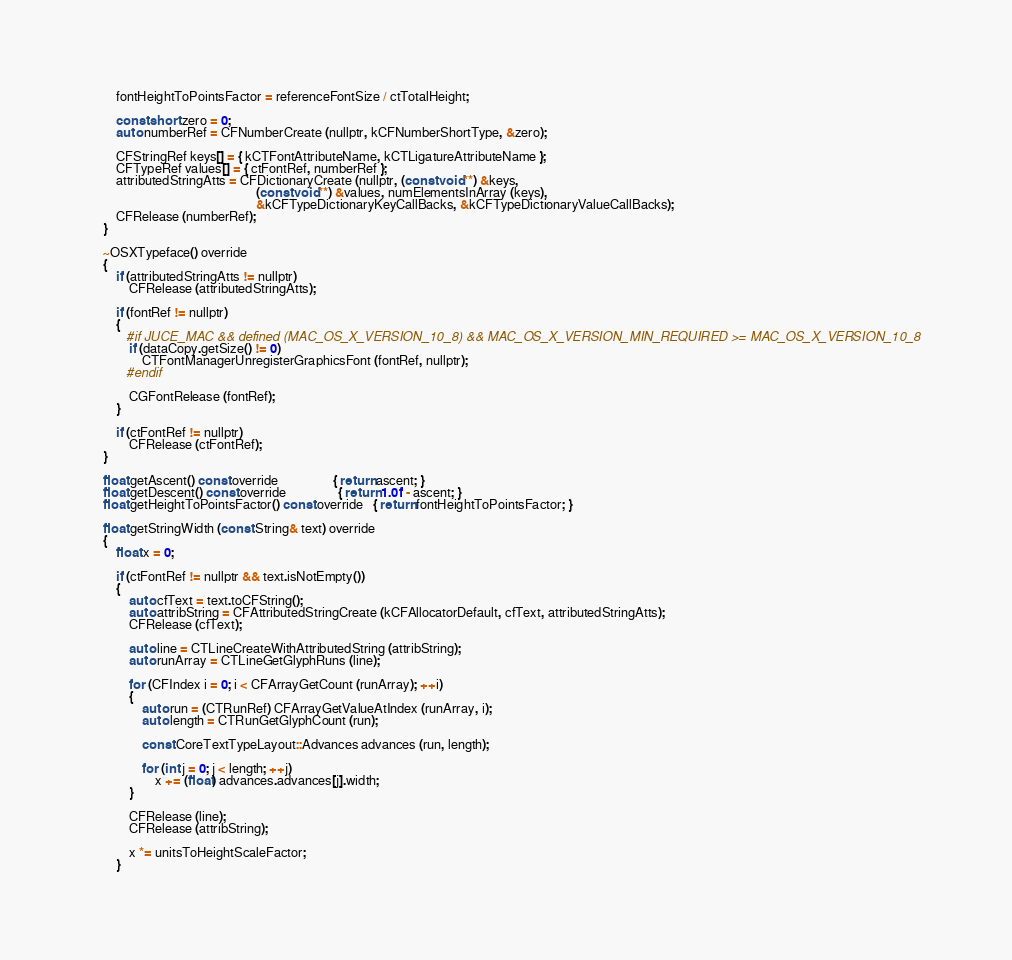Convert code to text. <code><loc_0><loc_0><loc_500><loc_500><_ObjectiveC_>
        fontHeightToPointsFactor = referenceFontSize / ctTotalHeight;

        const short zero = 0;
        auto numberRef = CFNumberCreate (nullptr, kCFNumberShortType, &zero);

        CFStringRef keys[] = { kCTFontAttributeName, kCTLigatureAttributeName };
        CFTypeRef values[] = { ctFontRef, numberRef };
        attributedStringAtts = CFDictionaryCreate (nullptr, (const void**) &keys,
                                                   (const void**) &values, numElementsInArray (keys),
                                                   &kCFTypeDictionaryKeyCallBacks, &kCFTypeDictionaryValueCallBacks);
        CFRelease (numberRef);
    }

    ~OSXTypeface() override
    {
        if (attributedStringAtts != nullptr)
            CFRelease (attributedStringAtts);

        if (fontRef != nullptr)
        {
           #if JUCE_MAC && defined (MAC_OS_X_VERSION_10_8) && MAC_OS_X_VERSION_MIN_REQUIRED >= MAC_OS_X_VERSION_10_8
            if (dataCopy.getSize() != 0)
                CTFontManagerUnregisterGraphicsFont (fontRef, nullptr);
           #endif

            CGFontRelease (fontRef);
        }

        if (ctFontRef != nullptr)
            CFRelease (ctFontRef);
    }

    float getAscent() const override                 { return ascent; }
    float getDescent() const override                { return 1.0f - ascent; }
    float getHeightToPointsFactor() const override   { return fontHeightToPointsFactor; }

    float getStringWidth (const String& text) override
    {
        float x = 0;

        if (ctFontRef != nullptr && text.isNotEmpty())
        {
            auto cfText = text.toCFString();
            auto attribString = CFAttributedStringCreate (kCFAllocatorDefault, cfText, attributedStringAtts);
            CFRelease (cfText);

            auto line = CTLineCreateWithAttributedString (attribString);
            auto runArray = CTLineGetGlyphRuns (line);

            for (CFIndex i = 0; i < CFArrayGetCount (runArray); ++i)
            {
                auto run = (CTRunRef) CFArrayGetValueAtIndex (runArray, i);
                auto length = CTRunGetGlyphCount (run);

                const CoreTextTypeLayout::Advances advances (run, length);

                for (int j = 0; j < length; ++j)
                    x += (float) advances.advances[j].width;
            }

            CFRelease (line);
            CFRelease (attribString);

            x *= unitsToHeightScaleFactor;
        }
</code> 